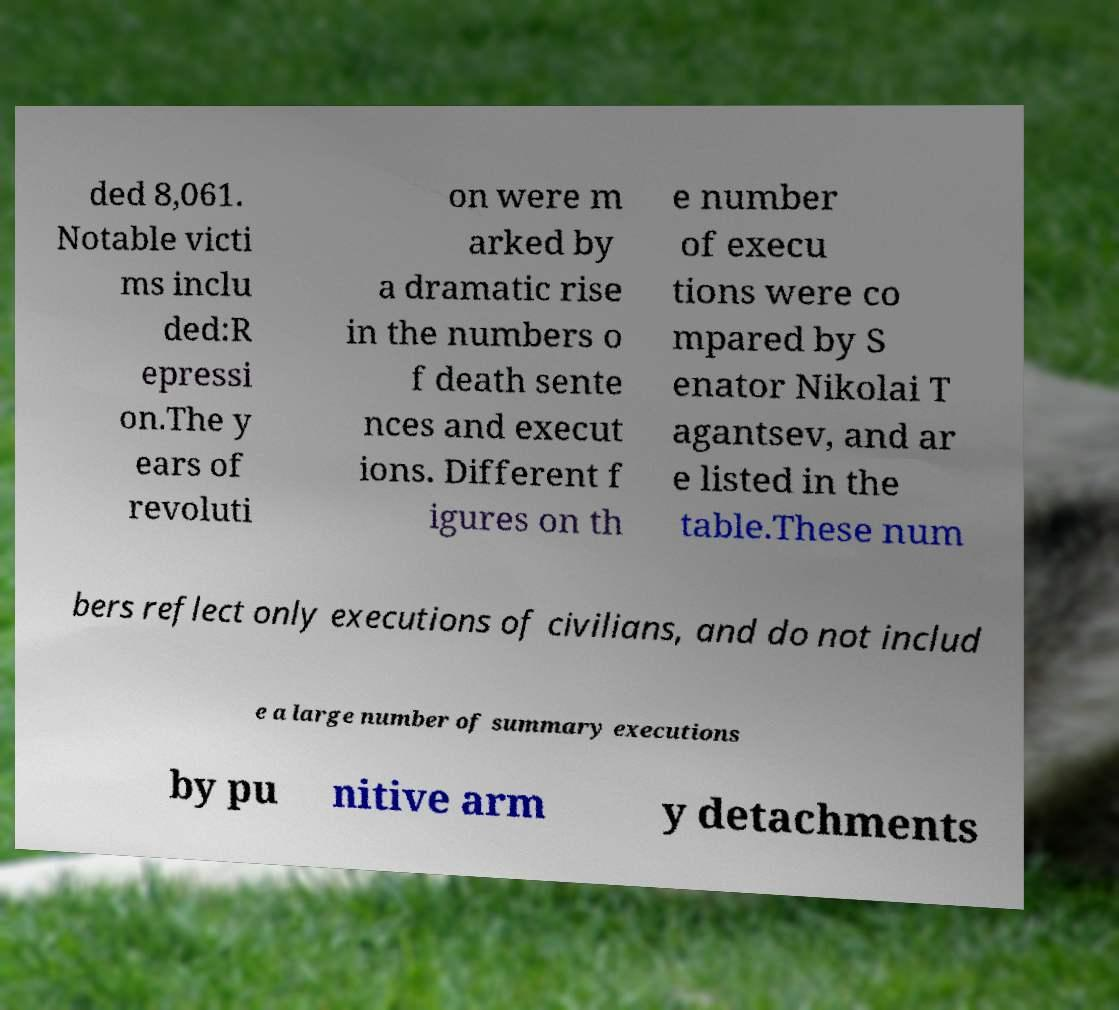Could you extract and type out the text from this image? ded 8,061. Notable victi ms inclu ded:R epressi on.The y ears of revoluti on were m arked by a dramatic rise in the numbers o f death sente nces and execut ions. Different f igures on th e number of execu tions were co mpared by S enator Nikolai T agantsev, and ar e listed in the table.These num bers reflect only executions of civilians, and do not includ e a large number of summary executions by pu nitive arm y detachments 